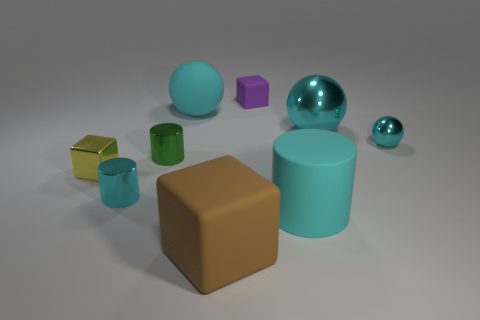Does the small metal cylinder in front of the tiny yellow block have the same color as the rubber ball?
Make the answer very short. Yes. There is a block that is both right of the cyan rubber ball and in front of the tiny purple rubber cube; what color is it?
Keep it short and to the point. Brown. What is the shape of the green metal thing that is the same size as the purple matte block?
Provide a short and direct response. Cylinder. Are there any gray metallic objects of the same shape as the small green object?
Ensure brevity in your answer.  No. There is a cyan cylinder that is on the left side of the matte sphere; is it the same size as the purple matte object?
Offer a very short reply. Yes. What size is the object that is behind the tiny cyan shiny cylinder and on the left side of the tiny green metallic cylinder?
Your response must be concise. Small. How many other objects are the same material as the purple object?
Keep it short and to the point. 3. What size is the metal cylinder that is left of the green metal object?
Offer a terse response. Small. Is the matte cylinder the same color as the tiny metal sphere?
Provide a succinct answer. Yes. What number of large objects are purple cubes or cyan things?
Provide a succinct answer. 3. 